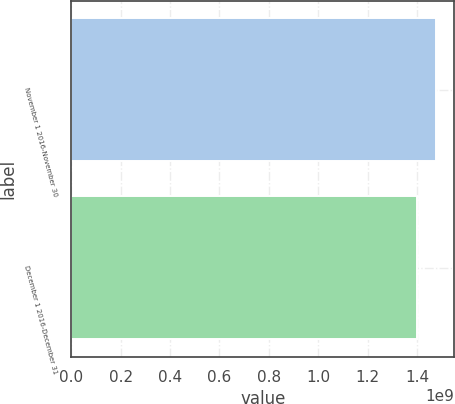<chart> <loc_0><loc_0><loc_500><loc_500><bar_chart><fcel>November 1 2016-November 30<fcel>December 1 2016-December 31<nl><fcel>1.47697e+09<fcel>1.40173e+09<nl></chart> 